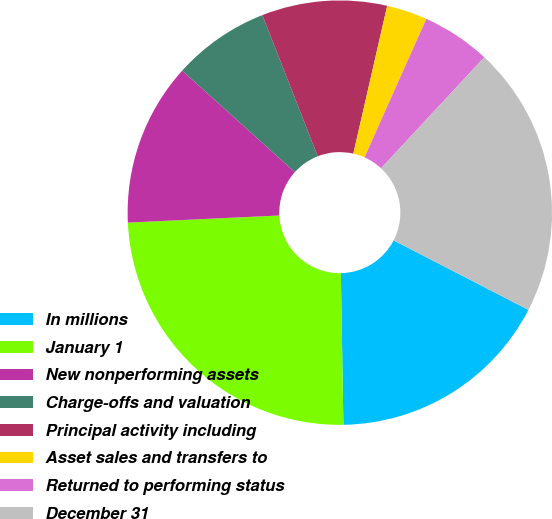Convert chart. <chart><loc_0><loc_0><loc_500><loc_500><pie_chart><fcel>In millions<fcel>January 1<fcel>New nonperforming assets<fcel>Charge-offs and valuation<fcel>Principal activity including<fcel>Asset sales and transfers to<fcel>Returned to performing status<fcel>December 31<nl><fcel>17.16%<fcel>24.52%<fcel>12.42%<fcel>7.38%<fcel>9.53%<fcel>3.1%<fcel>5.24%<fcel>20.65%<nl></chart> 